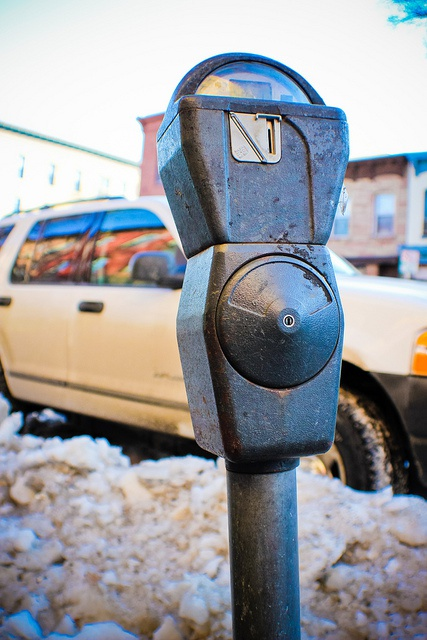Describe the objects in this image and their specific colors. I can see parking meter in lightblue, gray, and black tones and car in lightblue, lightgray, tan, and black tones in this image. 